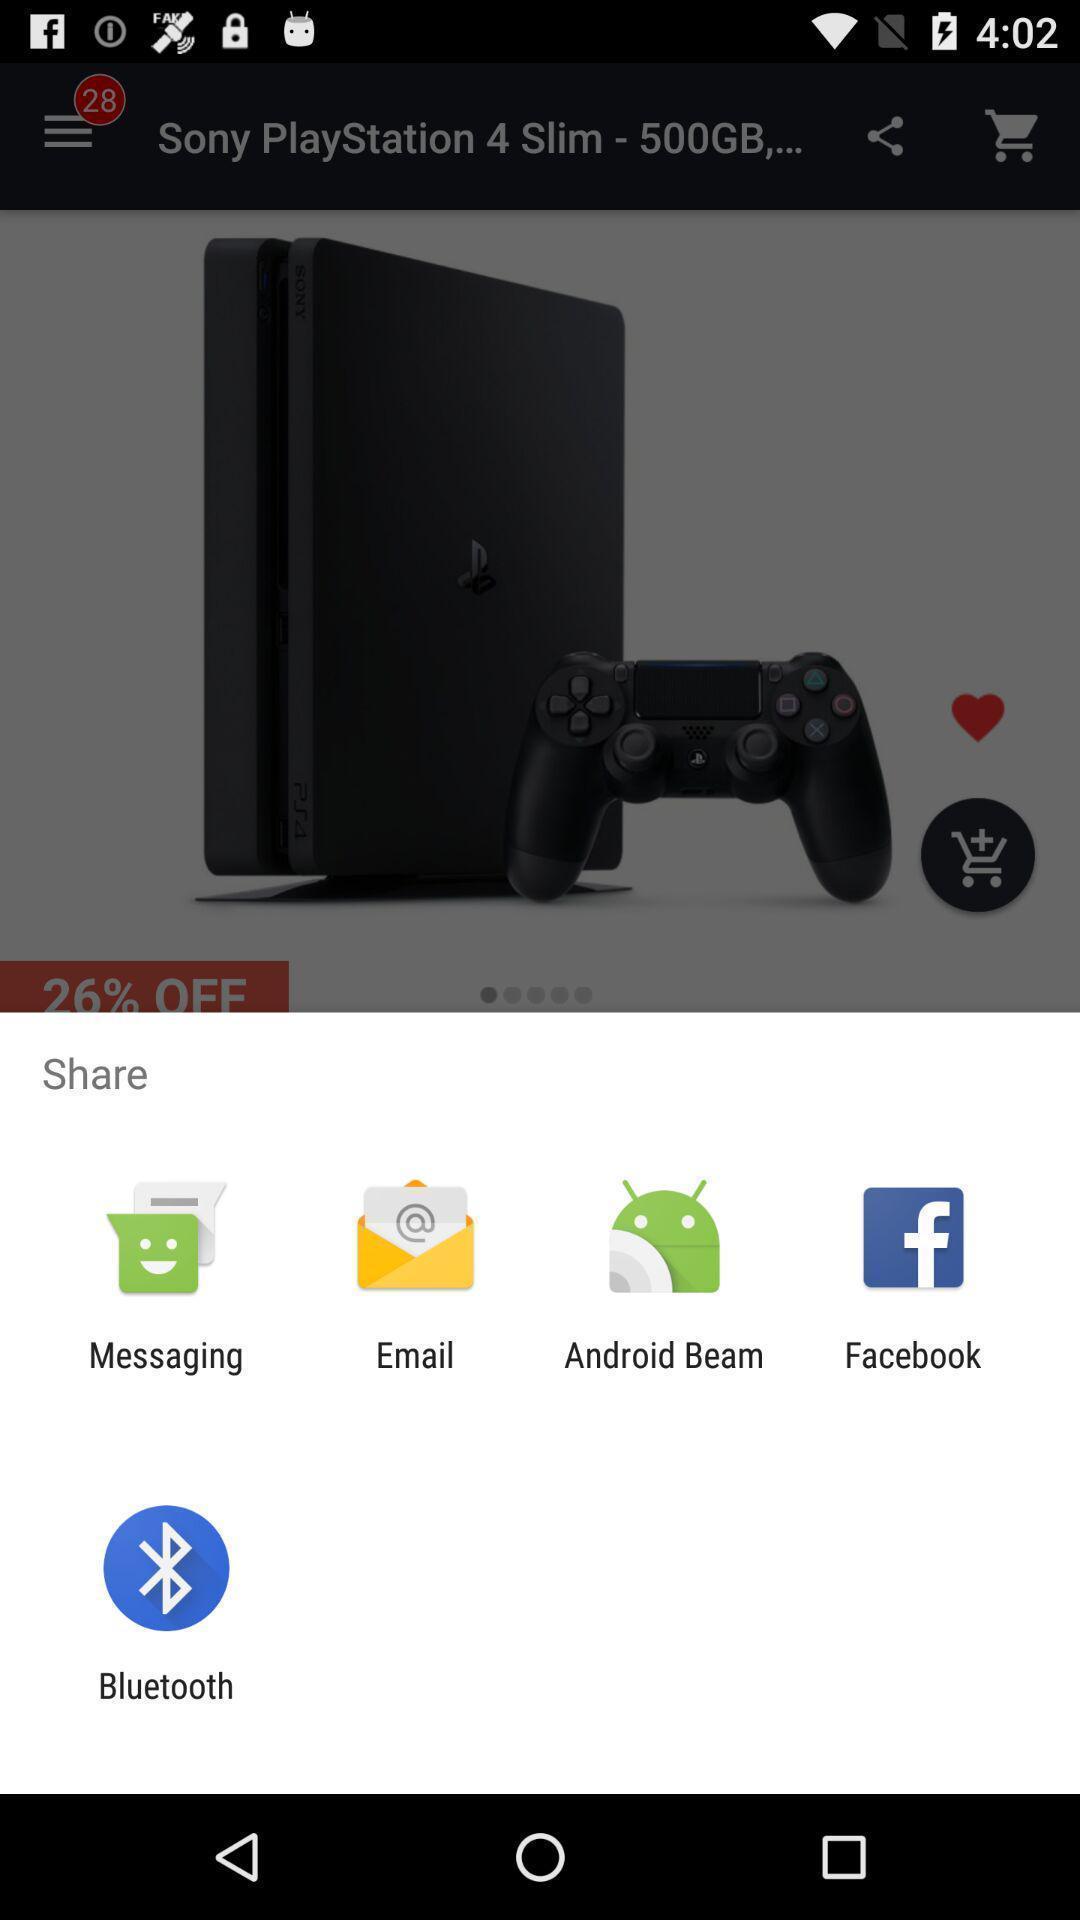What can you discern from this picture? Pop-up with sharing options on shopping app. 